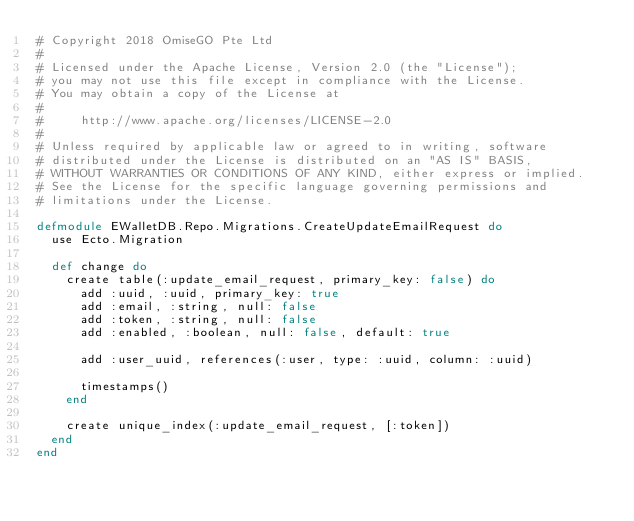Convert code to text. <code><loc_0><loc_0><loc_500><loc_500><_Elixir_># Copyright 2018 OmiseGO Pte Ltd
#
# Licensed under the Apache License, Version 2.0 (the "License");
# you may not use this file except in compliance with the License.
# You may obtain a copy of the License at
#
#     http://www.apache.org/licenses/LICENSE-2.0
#
# Unless required by applicable law or agreed to in writing, software
# distributed under the License is distributed on an "AS IS" BASIS,
# WITHOUT WARRANTIES OR CONDITIONS OF ANY KIND, either express or implied.
# See the License for the specific language governing permissions and
# limitations under the License.

defmodule EWalletDB.Repo.Migrations.CreateUpdateEmailRequest do
  use Ecto.Migration

  def change do
    create table(:update_email_request, primary_key: false) do
      add :uuid, :uuid, primary_key: true
      add :email, :string, null: false
      add :token, :string, null: false
      add :enabled, :boolean, null: false, default: true

      add :user_uuid, references(:user, type: :uuid, column: :uuid)

      timestamps()
    end

    create unique_index(:update_email_request, [:token])
  end
end
</code> 